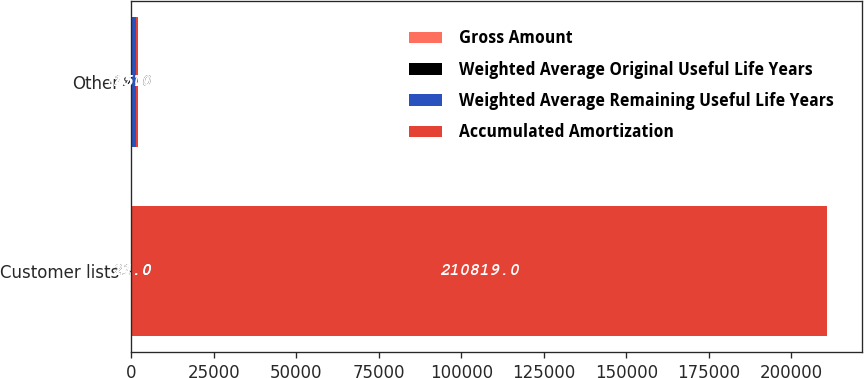Convert chart. <chart><loc_0><loc_0><loc_500><loc_500><stacked_bar_chart><ecel><fcel>Customer lists<fcel>Other<nl><fcel>Gross Amount<fcel>21<fcel>19<nl><fcel>Weighted Average Original Useful Life Years<fcel>14<fcel>17<nl><fcel>Weighted Average Remaining Useful Life Years<fcel>21<fcel>1450<nl><fcel>Accumulated Amortization<fcel>210819<fcel>457<nl></chart> 